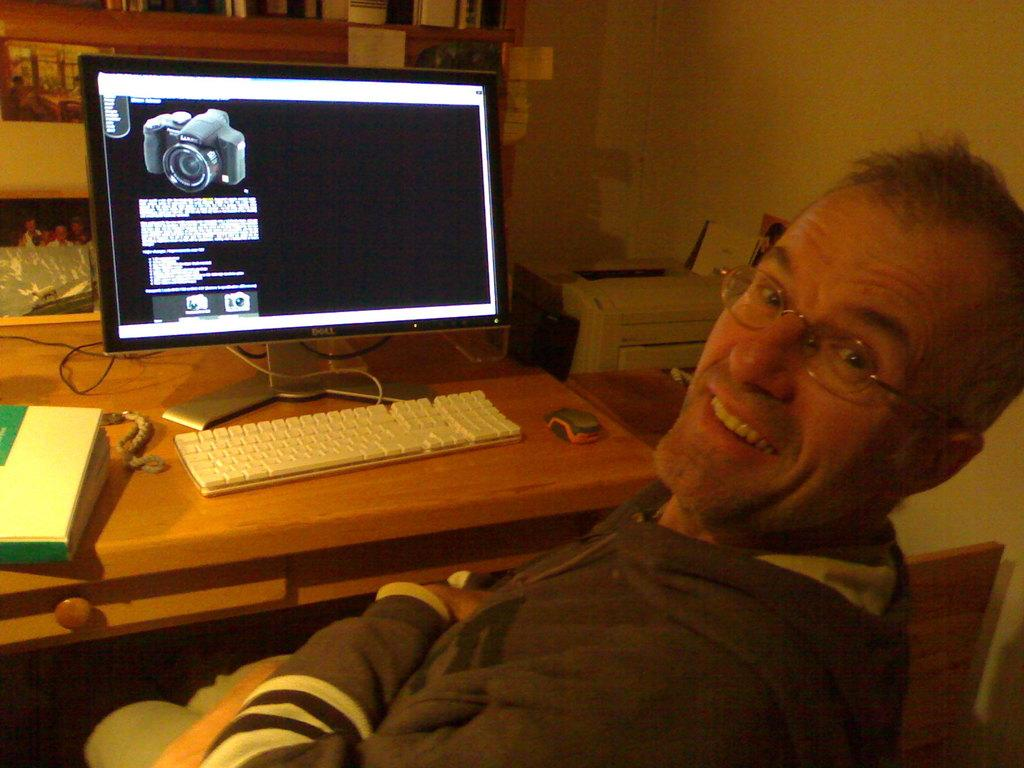What is the man in the image doing? The man is sitting in the image. What electronic device is present in the image? There is a monitor in the image. What is the man likely using to interact with the monitor? There is a keyboard in the image, which the man might be using. What is the man sitting at in the image? There is a table in the image, which the man is likely sitting at. Can you see a kitten playing with a club in the image? There is no kitten or club present in the image. 